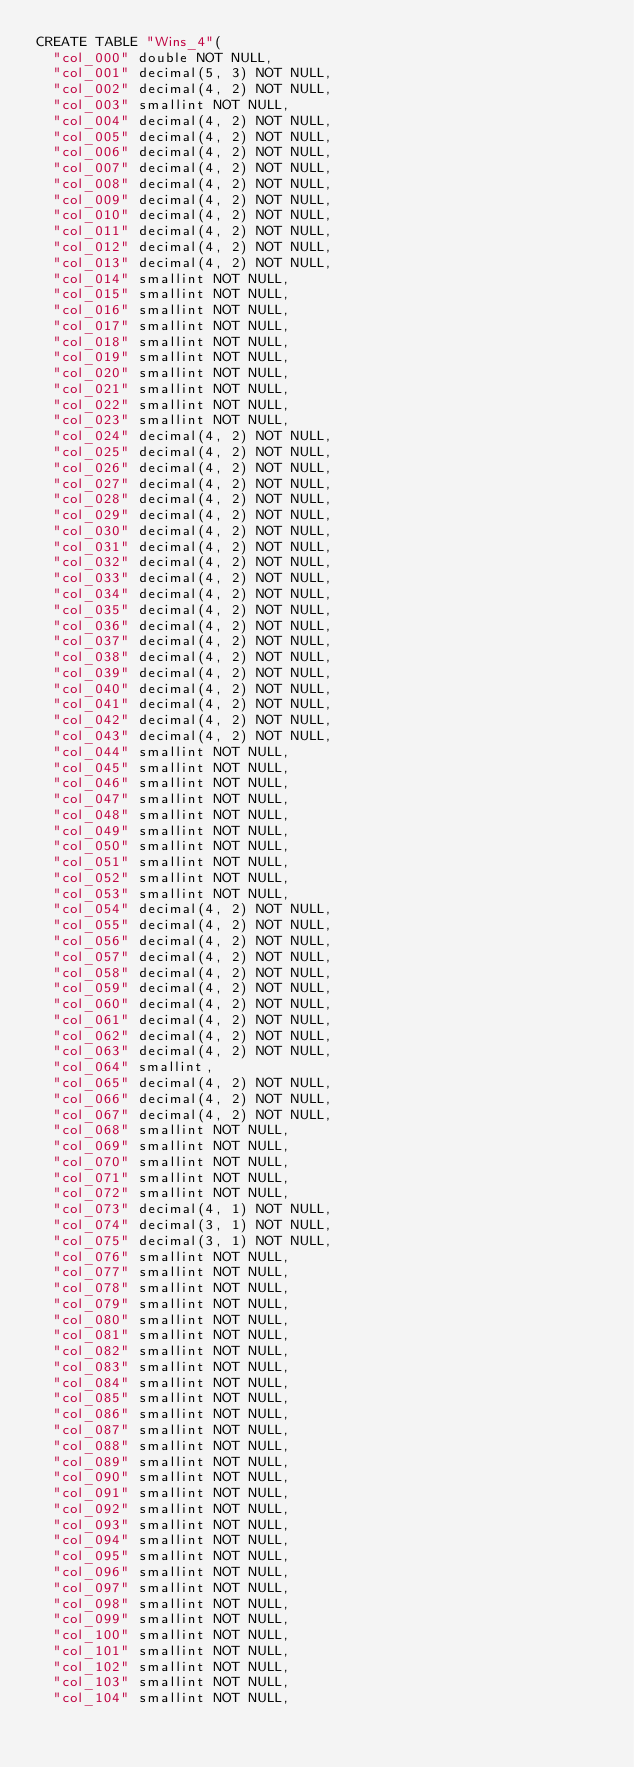<code> <loc_0><loc_0><loc_500><loc_500><_SQL_>CREATE TABLE "Wins_4"(
  "col_000" double NOT NULL,
  "col_001" decimal(5, 3) NOT NULL,
  "col_002" decimal(4, 2) NOT NULL,
  "col_003" smallint NOT NULL,
  "col_004" decimal(4, 2) NOT NULL,
  "col_005" decimal(4, 2) NOT NULL,
  "col_006" decimal(4, 2) NOT NULL,
  "col_007" decimal(4, 2) NOT NULL,
  "col_008" decimal(4, 2) NOT NULL,
  "col_009" decimal(4, 2) NOT NULL,
  "col_010" decimal(4, 2) NOT NULL,
  "col_011" decimal(4, 2) NOT NULL,
  "col_012" decimal(4, 2) NOT NULL,
  "col_013" decimal(4, 2) NOT NULL,
  "col_014" smallint NOT NULL,
  "col_015" smallint NOT NULL,
  "col_016" smallint NOT NULL,
  "col_017" smallint NOT NULL,
  "col_018" smallint NOT NULL,
  "col_019" smallint NOT NULL,
  "col_020" smallint NOT NULL,
  "col_021" smallint NOT NULL,
  "col_022" smallint NOT NULL,
  "col_023" smallint NOT NULL,
  "col_024" decimal(4, 2) NOT NULL,
  "col_025" decimal(4, 2) NOT NULL,
  "col_026" decimal(4, 2) NOT NULL,
  "col_027" decimal(4, 2) NOT NULL,
  "col_028" decimal(4, 2) NOT NULL,
  "col_029" decimal(4, 2) NOT NULL,
  "col_030" decimal(4, 2) NOT NULL,
  "col_031" decimal(4, 2) NOT NULL,
  "col_032" decimal(4, 2) NOT NULL,
  "col_033" decimal(4, 2) NOT NULL,
  "col_034" decimal(4, 2) NOT NULL,
  "col_035" decimal(4, 2) NOT NULL,
  "col_036" decimal(4, 2) NOT NULL,
  "col_037" decimal(4, 2) NOT NULL,
  "col_038" decimal(4, 2) NOT NULL,
  "col_039" decimal(4, 2) NOT NULL,
  "col_040" decimal(4, 2) NOT NULL,
  "col_041" decimal(4, 2) NOT NULL,
  "col_042" decimal(4, 2) NOT NULL,
  "col_043" decimal(4, 2) NOT NULL,
  "col_044" smallint NOT NULL,
  "col_045" smallint NOT NULL,
  "col_046" smallint NOT NULL,
  "col_047" smallint NOT NULL,
  "col_048" smallint NOT NULL,
  "col_049" smallint NOT NULL,
  "col_050" smallint NOT NULL,
  "col_051" smallint NOT NULL,
  "col_052" smallint NOT NULL,
  "col_053" smallint NOT NULL,
  "col_054" decimal(4, 2) NOT NULL,
  "col_055" decimal(4, 2) NOT NULL,
  "col_056" decimal(4, 2) NOT NULL,
  "col_057" decimal(4, 2) NOT NULL,
  "col_058" decimal(4, 2) NOT NULL,
  "col_059" decimal(4, 2) NOT NULL,
  "col_060" decimal(4, 2) NOT NULL,
  "col_061" decimal(4, 2) NOT NULL,
  "col_062" decimal(4, 2) NOT NULL,
  "col_063" decimal(4, 2) NOT NULL,
  "col_064" smallint,
  "col_065" decimal(4, 2) NOT NULL,
  "col_066" decimal(4, 2) NOT NULL,
  "col_067" decimal(4, 2) NOT NULL,
  "col_068" smallint NOT NULL,
  "col_069" smallint NOT NULL,
  "col_070" smallint NOT NULL,
  "col_071" smallint NOT NULL,
  "col_072" smallint NOT NULL,
  "col_073" decimal(4, 1) NOT NULL,
  "col_074" decimal(3, 1) NOT NULL,
  "col_075" decimal(3, 1) NOT NULL,
  "col_076" smallint NOT NULL,
  "col_077" smallint NOT NULL,
  "col_078" smallint NOT NULL,
  "col_079" smallint NOT NULL,
  "col_080" smallint NOT NULL,
  "col_081" smallint NOT NULL,
  "col_082" smallint NOT NULL,
  "col_083" smallint NOT NULL,
  "col_084" smallint NOT NULL,
  "col_085" smallint NOT NULL,
  "col_086" smallint NOT NULL,
  "col_087" smallint NOT NULL,
  "col_088" smallint NOT NULL,
  "col_089" smallint NOT NULL,
  "col_090" smallint NOT NULL,
  "col_091" smallint NOT NULL,
  "col_092" smallint NOT NULL,
  "col_093" smallint NOT NULL,
  "col_094" smallint NOT NULL,
  "col_095" smallint NOT NULL,
  "col_096" smallint NOT NULL,
  "col_097" smallint NOT NULL,
  "col_098" smallint NOT NULL,
  "col_099" smallint NOT NULL,
  "col_100" smallint NOT NULL,
  "col_101" smallint NOT NULL,
  "col_102" smallint NOT NULL,
  "col_103" smallint NOT NULL,
  "col_104" smallint NOT NULL,</code> 